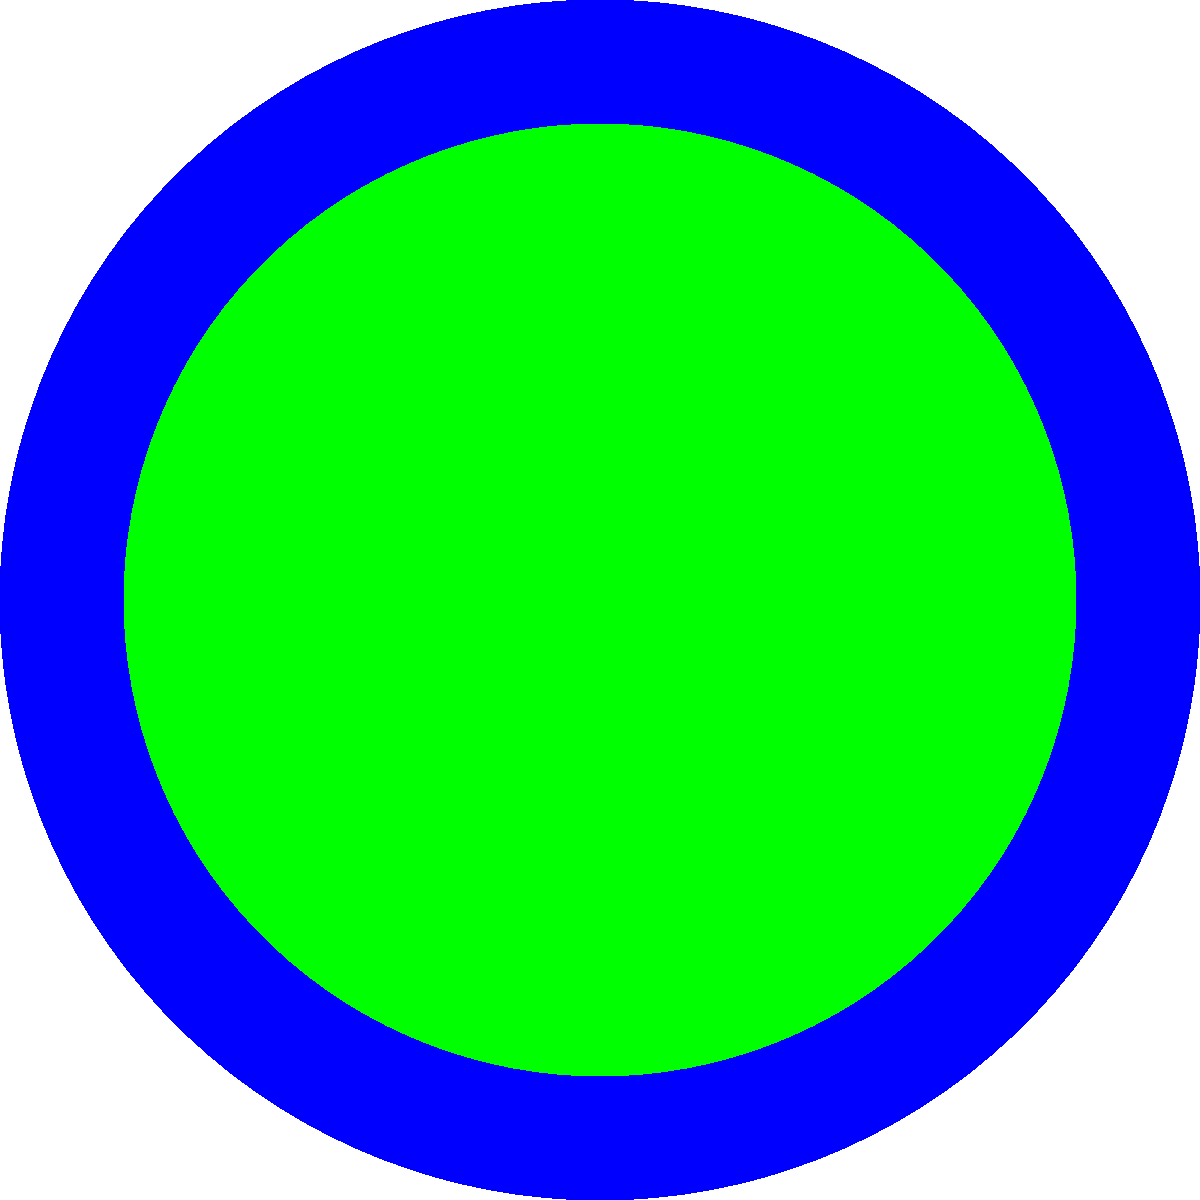In the polar coordinate heat map showing hotel guest traffic patterns, which time period consistently experiences the highest guest activity, and what might this indicate about celebrity arrivals or departures? To answer this question, we need to analyze the heat map:

1. The polar coordinate system represents a 24-hour clock, with each segment representing one hour.
2. The color intensity indicates the level of guest activity, with red being the highest and purple the lowest.
3. Examining the heat map, we can see that the reddest (most intense) areas are consistently around the 3-4 o'clock position.
4. This corresponds to 15:00-16:00 or 3-4 PM in the afternoon.
5. The high activity during this time might indicate:
   a) Check-in time for many guests
   b) Return of guests from daytime activities
   c) Arrival of celebrities for evening events or performances
6. For a concierge who tips off paparazzi, this time would be crucial for potential celebrity sightings.
7. The pattern suggests that celebrities might be arriving at the hotel during this time to prepare for evening engagements, making it an ideal time for paparazzi to be alerted.
Answer: 15:00-16:00 (3-4 PM); likely celebrity arrivals for evening events 